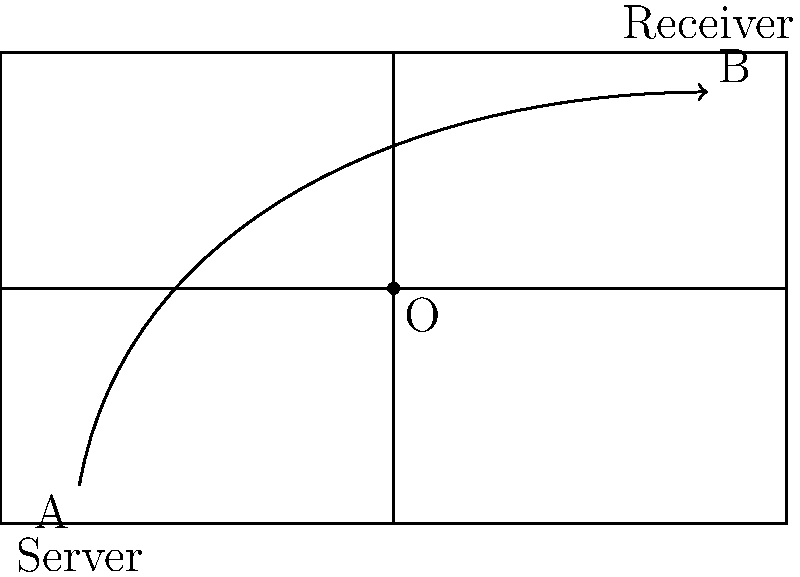In a tennis serve, the ball's trajectory from point A to point B can be modeled as a rotation around point O. If this rotation is repeated, it generates a cyclic group. Assuming it takes 4 such rotations for the ball to return to its starting position, what is the order of this cyclic group? Let's approach this step-by-step:

1) In group theory, a cyclic group is a group that can be generated by a single element, called the generator.

2) In this case, the generator is the rotation that moves the ball from A to B.

3) We're told that it takes 4 such rotations for the ball to return to its starting position. This means:
   - 1 rotation: A to B
   - 2 rotations: B to C (not shown)
   - 3 rotations: C to D (not shown)
   - 4 rotations: D back to A

4) In group theory, the number of elements in a group is called its order.

5) Since it takes 4 rotations to complete a full cycle and return to the starting point, the group has 4 distinct elements:
   {e, r, r², r³}
   where e is the identity element (no rotation) and r is the generator (one rotation).

6) Therefore, the order of this cyclic group is 4.

This aligns with Coco Gauff's powerful serves, which often follow a precise, repeating pattern.
Answer: 4 